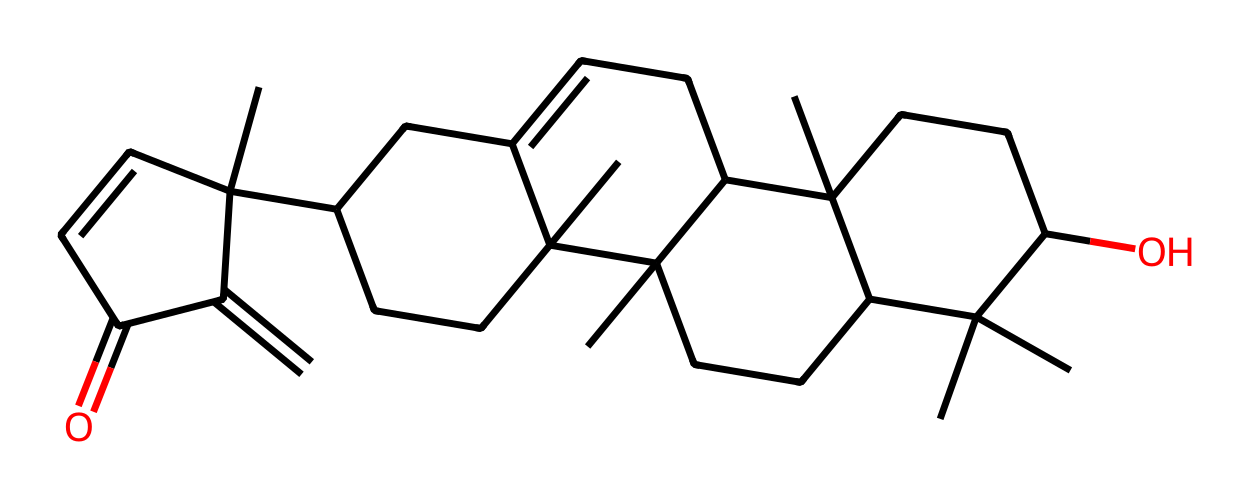What is the molecular formula of boswellic acid? By analyzing the SMILES representation and counting the carbon, hydrogen, and oxygen atoms, we determine that boswellic acid has the molecular formula C30H48O3.
Answer: C30H48O3 How many rings are present in the chemical structure? Looking at the SMILES string and identifying cyclic structures, we can determine that there are four rings in the boswellic acid structure.
Answer: 4 What type of chemical structure is boswellic acid classified as? Based on the presence of multiple carbon rings and a hydroxyl group, boswellic acid is classified as a triterpenoid.
Answer: triterpenoid Which functional group is present in boswellic acid? The presence of the -OH group in the structure indicates that the functional group in boswellic acid is a hydroxyl group.
Answer: hydroxyl How many double bonds are present in boswellic acid? By analyzing the SMILES string for double bonds (those indicated with '='), we find that there are two double bonds in the boswellic acid structure.
Answer: 2 What is the primary scent category of boswellic acid? Boswellic acid's association with the essential oil of frankincense links it primarily to resinous and woody scent categories.
Answer: resinous and woody Why might boswellic acid contribute to the therapeutic properties of frankincense? The complex structure of boswellic acid, with its rings and functional groups, is believed to interact with biological systems, contributing to the resin's known anti-inflammatory and medicinal properties.
Answer: anti-inflammatory and medicinal 